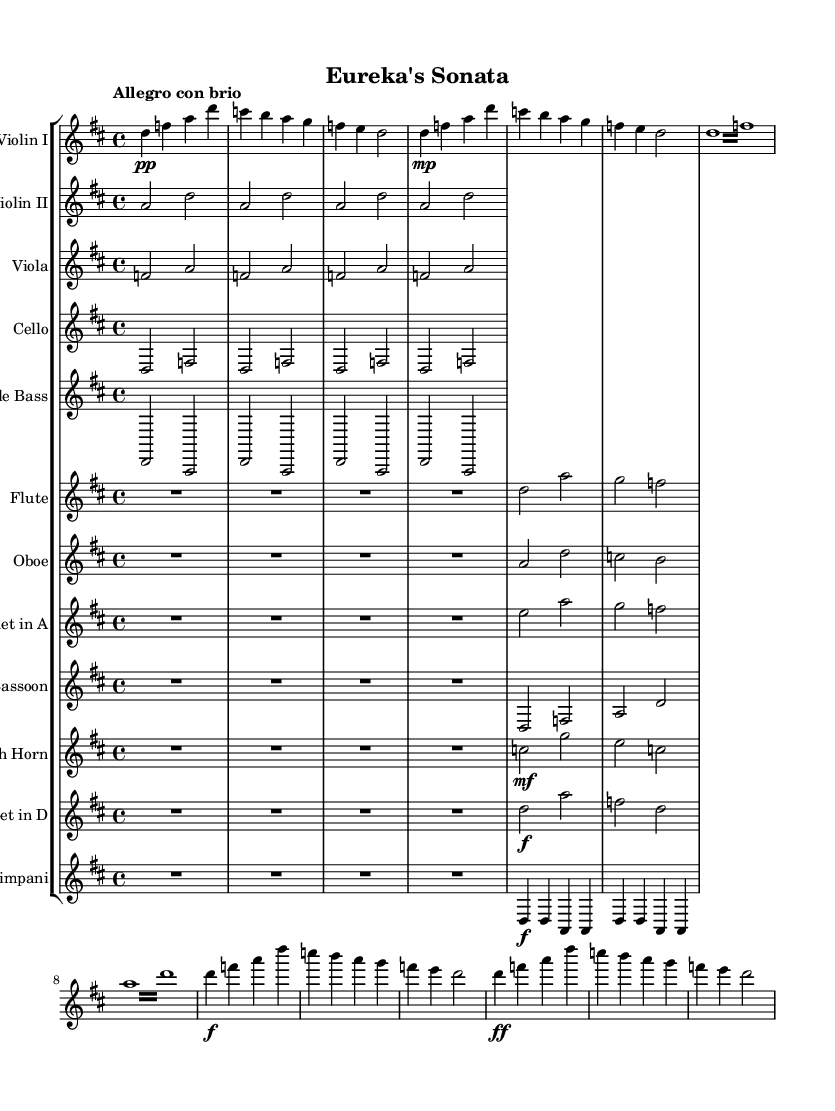what is the key signature of this music? The key signature, indicated by the number of sharps or flats at the beginning of the staff, shows that this piece is in D major, which has two sharps (F# and C#).
Answer: D major what is the time signature of this music? The time signature is indicated at the beginning of the score as 4/4, meaning there are four beats in a measure and the quarter note gets one beat.
Answer: 4/4 what is the dynamic marking for the introduction section? The dynamic marking for the introduction, as indicated in the first few measures, is pianissimo, which is notated as "pp."
Answer: pp how many instruments are included in this symphony? By counting the different staves in the score, we can see that there are 12 instruments represented, including strings, woodwinds, brass, and percussion.
Answer: 12 what is the tempo marking for this piece? The tempo marking is given at the beginning of the score as "Allegro con brio," indicating a lively and spirited pace.
Answer: Allegro con brio which instruments play the simplified parts throughout the piece? The simplified parts are shown for Violin II, Viola, Cello, Double Bass, Flute, Oboe, Bassoon, French Horn, and Trumpet in D, as they have largely repetitive and simpler lines compared to the Violin I.
Answer: Violin II, Viola, Cello, Double Bass, Flute, Oboe, Bassoon, French Horn, Trumpet in D what indicates the coda section in this symphony? The coda section is typically indicated by the name "Coda" in the sheet music, often appearing above the relevant measures after the recapitulation, which focuses on bringing the main themes back together.
Answer: Coda 